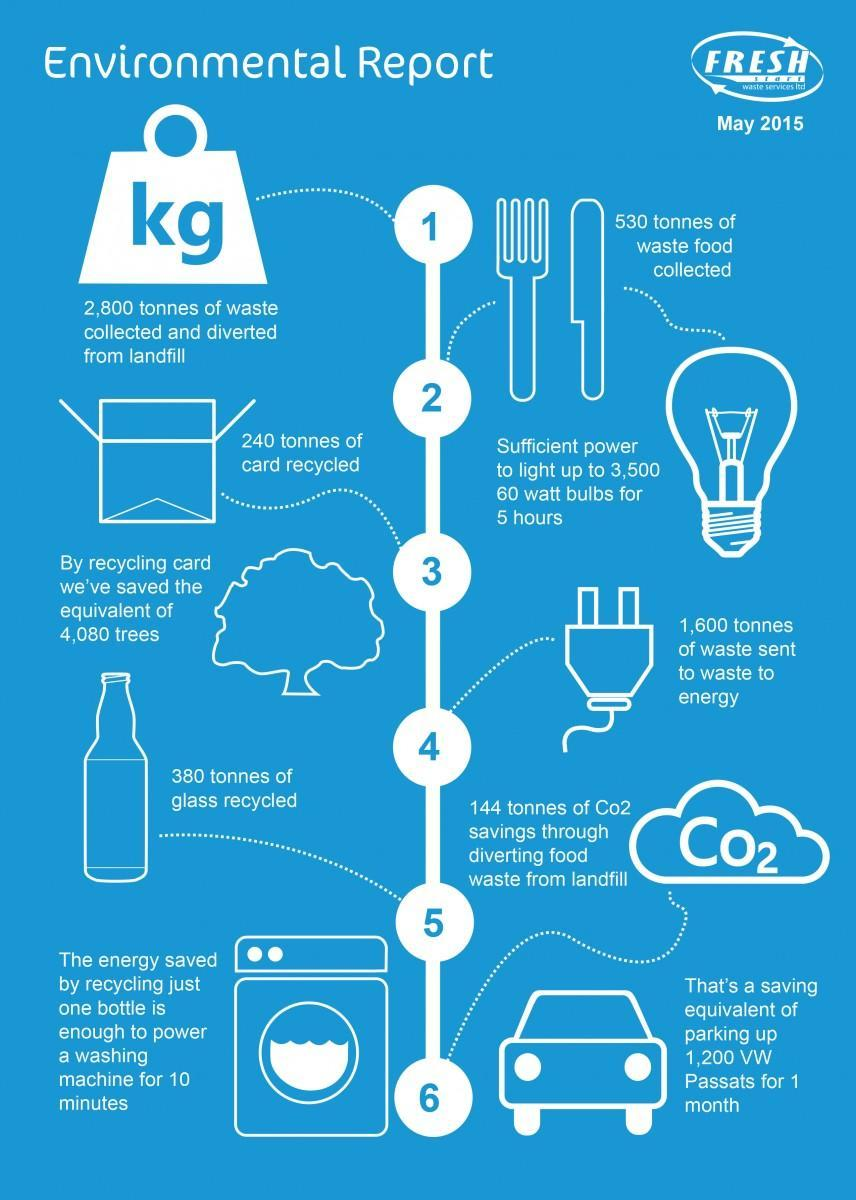How many tonnes of waste food was collected among the 2,800 tones of waste?
Answer the question with a short phrase. 530 240 tonnes of card recycled amounted to the what? saving the equivalent of 4,080 trees 